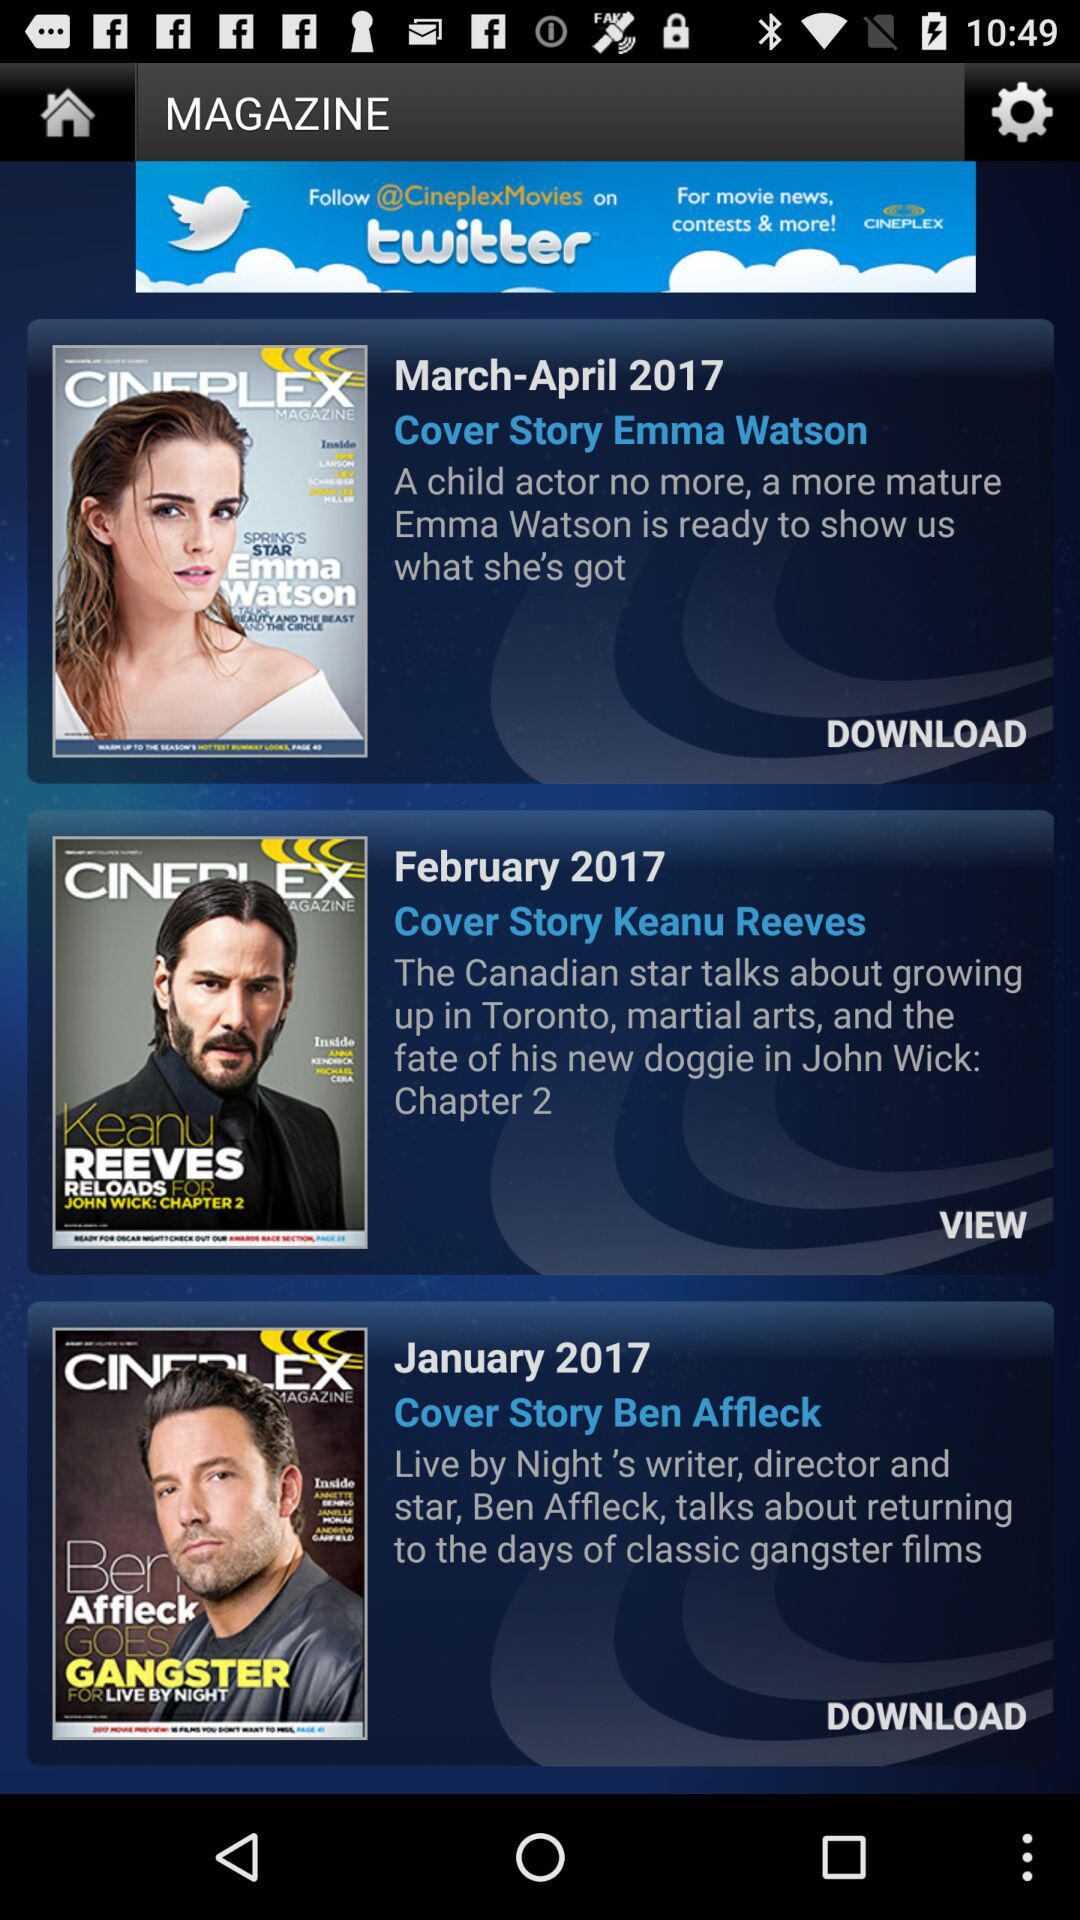Is cover story Emma Watson downloaded or undownloaded?
When the provided information is insufficient, respond with <no answer>. <no answer> 